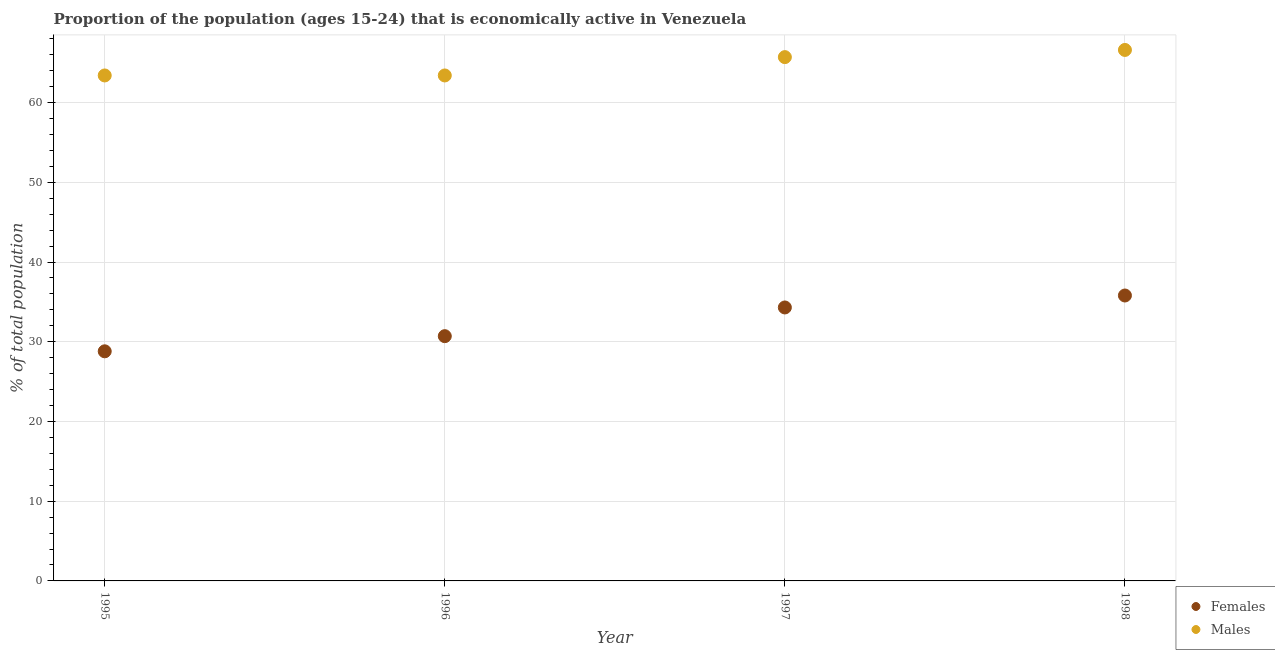How many different coloured dotlines are there?
Provide a succinct answer. 2. What is the percentage of economically active female population in 1996?
Your answer should be very brief. 30.7. Across all years, what is the maximum percentage of economically active female population?
Offer a terse response. 35.8. Across all years, what is the minimum percentage of economically active female population?
Ensure brevity in your answer.  28.8. In which year was the percentage of economically active female population minimum?
Your answer should be compact. 1995. What is the total percentage of economically active male population in the graph?
Your answer should be compact. 259.1. What is the difference between the percentage of economically active male population in 1996 and that in 1997?
Ensure brevity in your answer.  -2.3. What is the difference between the percentage of economically active female population in 1997 and the percentage of economically active male population in 1996?
Provide a succinct answer. -29.1. What is the average percentage of economically active male population per year?
Offer a terse response. 64.77. In the year 1995, what is the difference between the percentage of economically active female population and percentage of economically active male population?
Give a very brief answer. -34.6. In how many years, is the percentage of economically active male population greater than 32 %?
Your answer should be compact. 4. What is the ratio of the percentage of economically active female population in 1995 to that in 1998?
Your response must be concise. 0.8. Is the percentage of economically active female population in 1995 less than that in 1997?
Make the answer very short. Yes. What is the difference between the highest and the second highest percentage of economically active male population?
Your answer should be compact. 0.9. What is the difference between the highest and the lowest percentage of economically active female population?
Provide a short and direct response. 7. Does the percentage of economically active female population monotonically increase over the years?
Make the answer very short. Yes. Is the percentage of economically active male population strictly greater than the percentage of economically active female population over the years?
Make the answer very short. Yes. Does the graph contain any zero values?
Your answer should be compact. No. How many legend labels are there?
Provide a short and direct response. 2. How are the legend labels stacked?
Offer a very short reply. Vertical. What is the title of the graph?
Ensure brevity in your answer.  Proportion of the population (ages 15-24) that is economically active in Venezuela. What is the label or title of the X-axis?
Your answer should be compact. Year. What is the label or title of the Y-axis?
Offer a very short reply. % of total population. What is the % of total population of Females in 1995?
Make the answer very short. 28.8. What is the % of total population of Males in 1995?
Your answer should be compact. 63.4. What is the % of total population of Females in 1996?
Offer a very short reply. 30.7. What is the % of total population in Males in 1996?
Ensure brevity in your answer.  63.4. What is the % of total population in Females in 1997?
Your answer should be very brief. 34.3. What is the % of total population in Males in 1997?
Offer a terse response. 65.7. What is the % of total population of Females in 1998?
Offer a very short reply. 35.8. What is the % of total population in Males in 1998?
Offer a terse response. 66.6. Across all years, what is the maximum % of total population in Females?
Offer a very short reply. 35.8. Across all years, what is the maximum % of total population of Males?
Give a very brief answer. 66.6. Across all years, what is the minimum % of total population in Females?
Your answer should be compact. 28.8. Across all years, what is the minimum % of total population in Males?
Offer a terse response. 63.4. What is the total % of total population of Females in the graph?
Keep it short and to the point. 129.6. What is the total % of total population of Males in the graph?
Provide a succinct answer. 259.1. What is the difference between the % of total population in Males in 1995 and that in 1996?
Give a very brief answer. 0. What is the difference between the % of total population in Females in 1995 and that in 1997?
Provide a succinct answer. -5.5. What is the difference between the % of total population of Males in 1995 and that in 1997?
Your answer should be very brief. -2.3. What is the difference between the % of total population of Males in 1995 and that in 1998?
Offer a very short reply. -3.2. What is the difference between the % of total population of Females in 1996 and that in 1998?
Your answer should be compact. -5.1. What is the difference between the % of total population of Females in 1997 and that in 1998?
Provide a succinct answer. -1.5. What is the difference between the % of total population in Females in 1995 and the % of total population in Males in 1996?
Make the answer very short. -34.6. What is the difference between the % of total population of Females in 1995 and the % of total population of Males in 1997?
Provide a succinct answer. -36.9. What is the difference between the % of total population in Females in 1995 and the % of total population in Males in 1998?
Provide a short and direct response. -37.8. What is the difference between the % of total population of Females in 1996 and the % of total population of Males in 1997?
Offer a very short reply. -35. What is the difference between the % of total population in Females in 1996 and the % of total population in Males in 1998?
Keep it short and to the point. -35.9. What is the difference between the % of total population in Females in 1997 and the % of total population in Males in 1998?
Your response must be concise. -32.3. What is the average % of total population of Females per year?
Make the answer very short. 32.4. What is the average % of total population in Males per year?
Ensure brevity in your answer.  64.78. In the year 1995, what is the difference between the % of total population in Females and % of total population in Males?
Provide a short and direct response. -34.6. In the year 1996, what is the difference between the % of total population in Females and % of total population in Males?
Your response must be concise. -32.7. In the year 1997, what is the difference between the % of total population of Females and % of total population of Males?
Provide a succinct answer. -31.4. In the year 1998, what is the difference between the % of total population of Females and % of total population of Males?
Provide a short and direct response. -30.8. What is the ratio of the % of total population of Females in 1995 to that in 1996?
Offer a very short reply. 0.94. What is the ratio of the % of total population of Females in 1995 to that in 1997?
Your answer should be compact. 0.84. What is the ratio of the % of total population of Females in 1995 to that in 1998?
Your response must be concise. 0.8. What is the ratio of the % of total population of Females in 1996 to that in 1997?
Your response must be concise. 0.9. What is the ratio of the % of total population in Males in 1996 to that in 1997?
Provide a succinct answer. 0.96. What is the ratio of the % of total population in Females in 1996 to that in 1998?
Ensure brevity in your answer.  0.86. What is the ratio of the % of total population of Males in 1996 to that in 1998?
Provide a succinct answer. 0.95. What is the ratio of the % of total population of Females in 1997 to that in 1998?
Provide a succinct answer. 0.96. What is the ratio of the % of total population in Males in 1997 to that in 1998?
Keep it short and to the point. 0.99. What is the difference between the highest and the second highest % of total population in Females?
Give a very brief answer. 1.5. What is the difference between the highest and the second highest % of total population of Males?
Your answer should be compact. 0.9. 